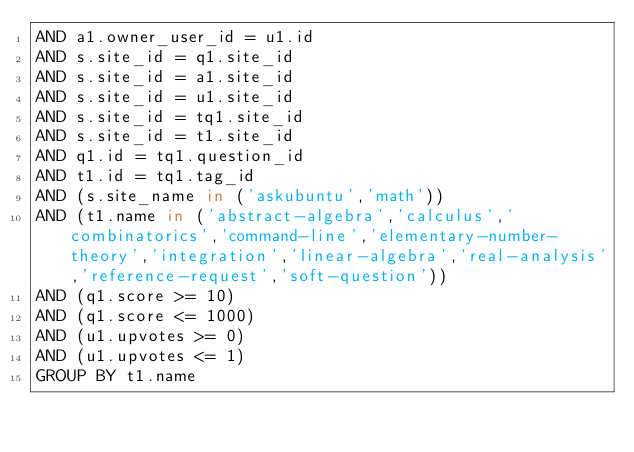Convert code to text. <code><loc_0><loc_0><loc_500><loc_500><_SQL_>AND a1.owner_user_id = u1.id
AND s.site_id = q1.site_id
AND s.site_id = a1.site_id
AND s.site_id = u1.site_id
AND s.site_id = tq1.site_id
AND s.site_id = t1.site_id
AND q1.id = tq1.question_id
AND t1.id = tq1.tag_id
AND (s.site_name in ('askubuntu','math'))
AND (t1.name in ('abstract-algebra','calculus','combinatorics','command-line','elementary-number-theory','integration','linear-algebra','real-analysis','reference-request','soft-question'))
AND (q1.score >= 10)
AND (q1.score <= 1000)
AND (u1.upvotes >= 0)
AND (u1.upvotes <= 1)
GROUP BY t1.name</code> 